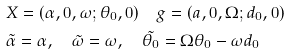Convert formula to latex. <formula><loc_0><loc_0><loc_500><loc_500>& X = ( \alpha , 0 , \omega ; \theta _ { 0 } , 0 ) \quad g = ( a , 0 , \Omega ; d _ { 0 } , 0 ) \\ & \tilde { \alpha } = \alpha , \quad \tilde { \omega } = \omega , \quad \tilde { \theta _ { 0 } } = \Omega \theta _ { 0 } - \omega d _ { 0 }</formula> 